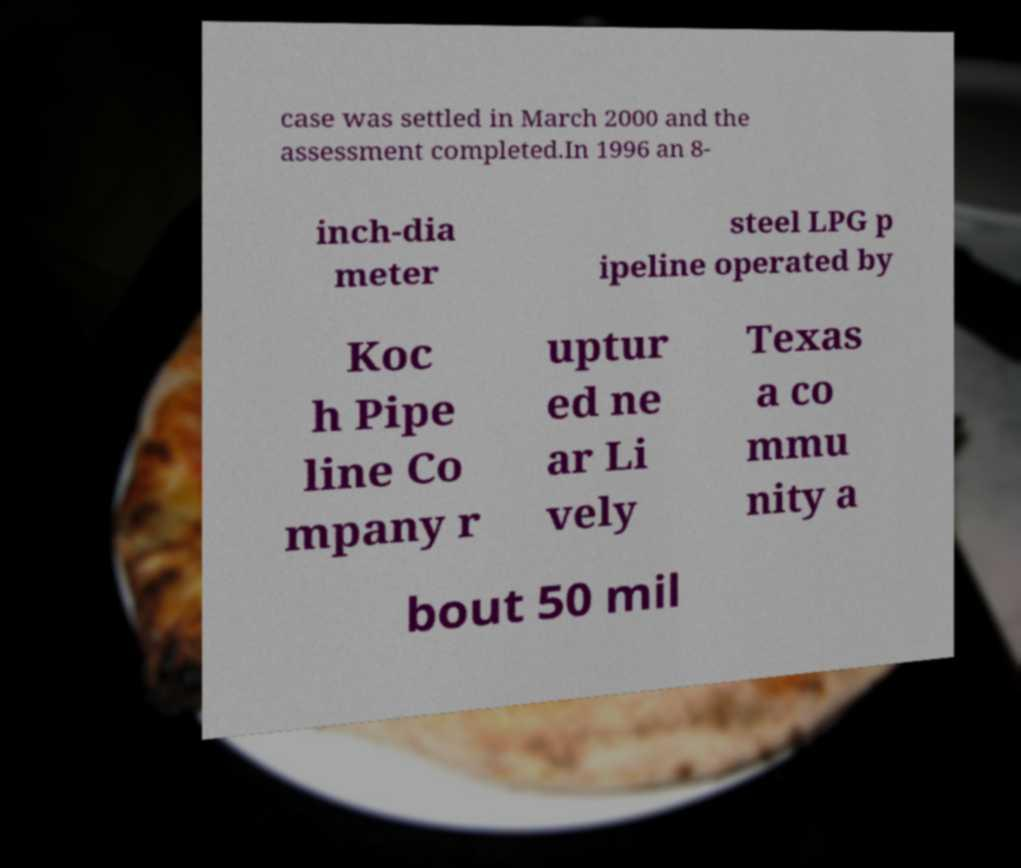Could you extract and type out the text from this image? case was settled in March 2000 and the assessment completed.In 1996 an 8- inch-dia meter steel LPG p ipeline operated by Koc h Pipe line Co mpany r uptur ed ne ar Li vely Texas a co mmu nity a bout 50 mil 